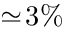Convert formula to latex. <formula><loc_0><loc_0><loc_500><loc_500>\simeq \, 3 \%</formula> 